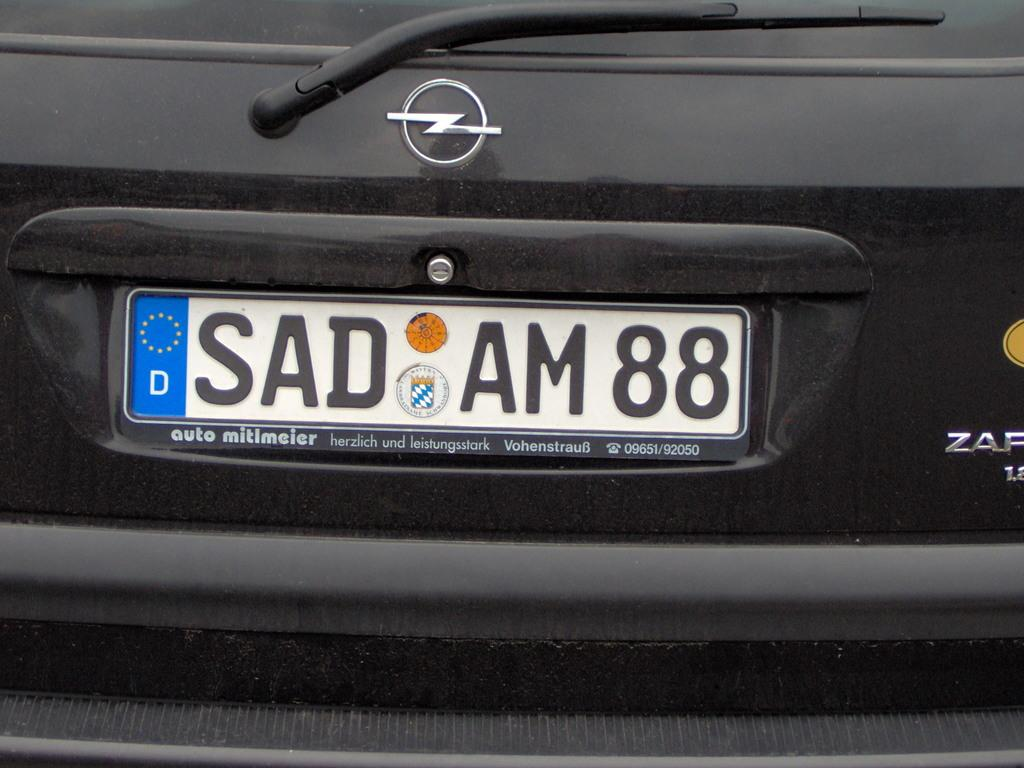<image>
Provide a brief description of the given image. A german license plate (SAD AM88) on a black vehicle. 